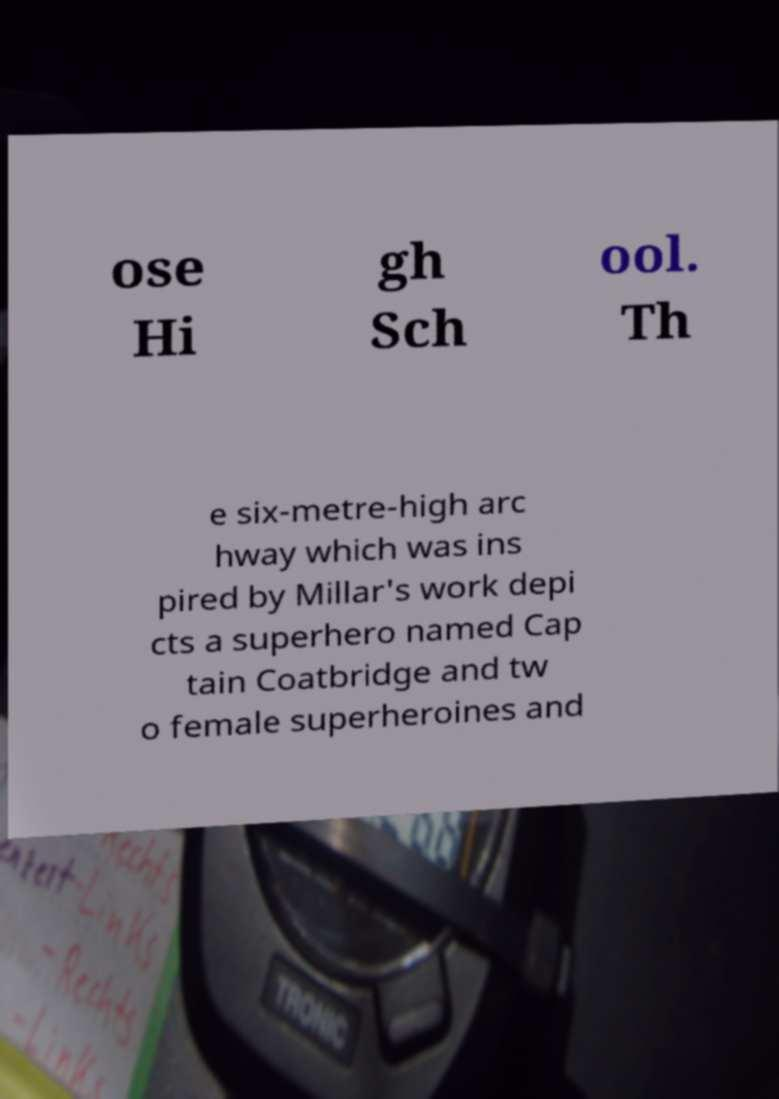Could you extract and type out the text from this image? ose Hi gh Sch ool. Th e six-metre-high arc hway which was ins pired by Millar's work depi cts a superhero named Cap tain Coatbridge and tw o female superheroines and 